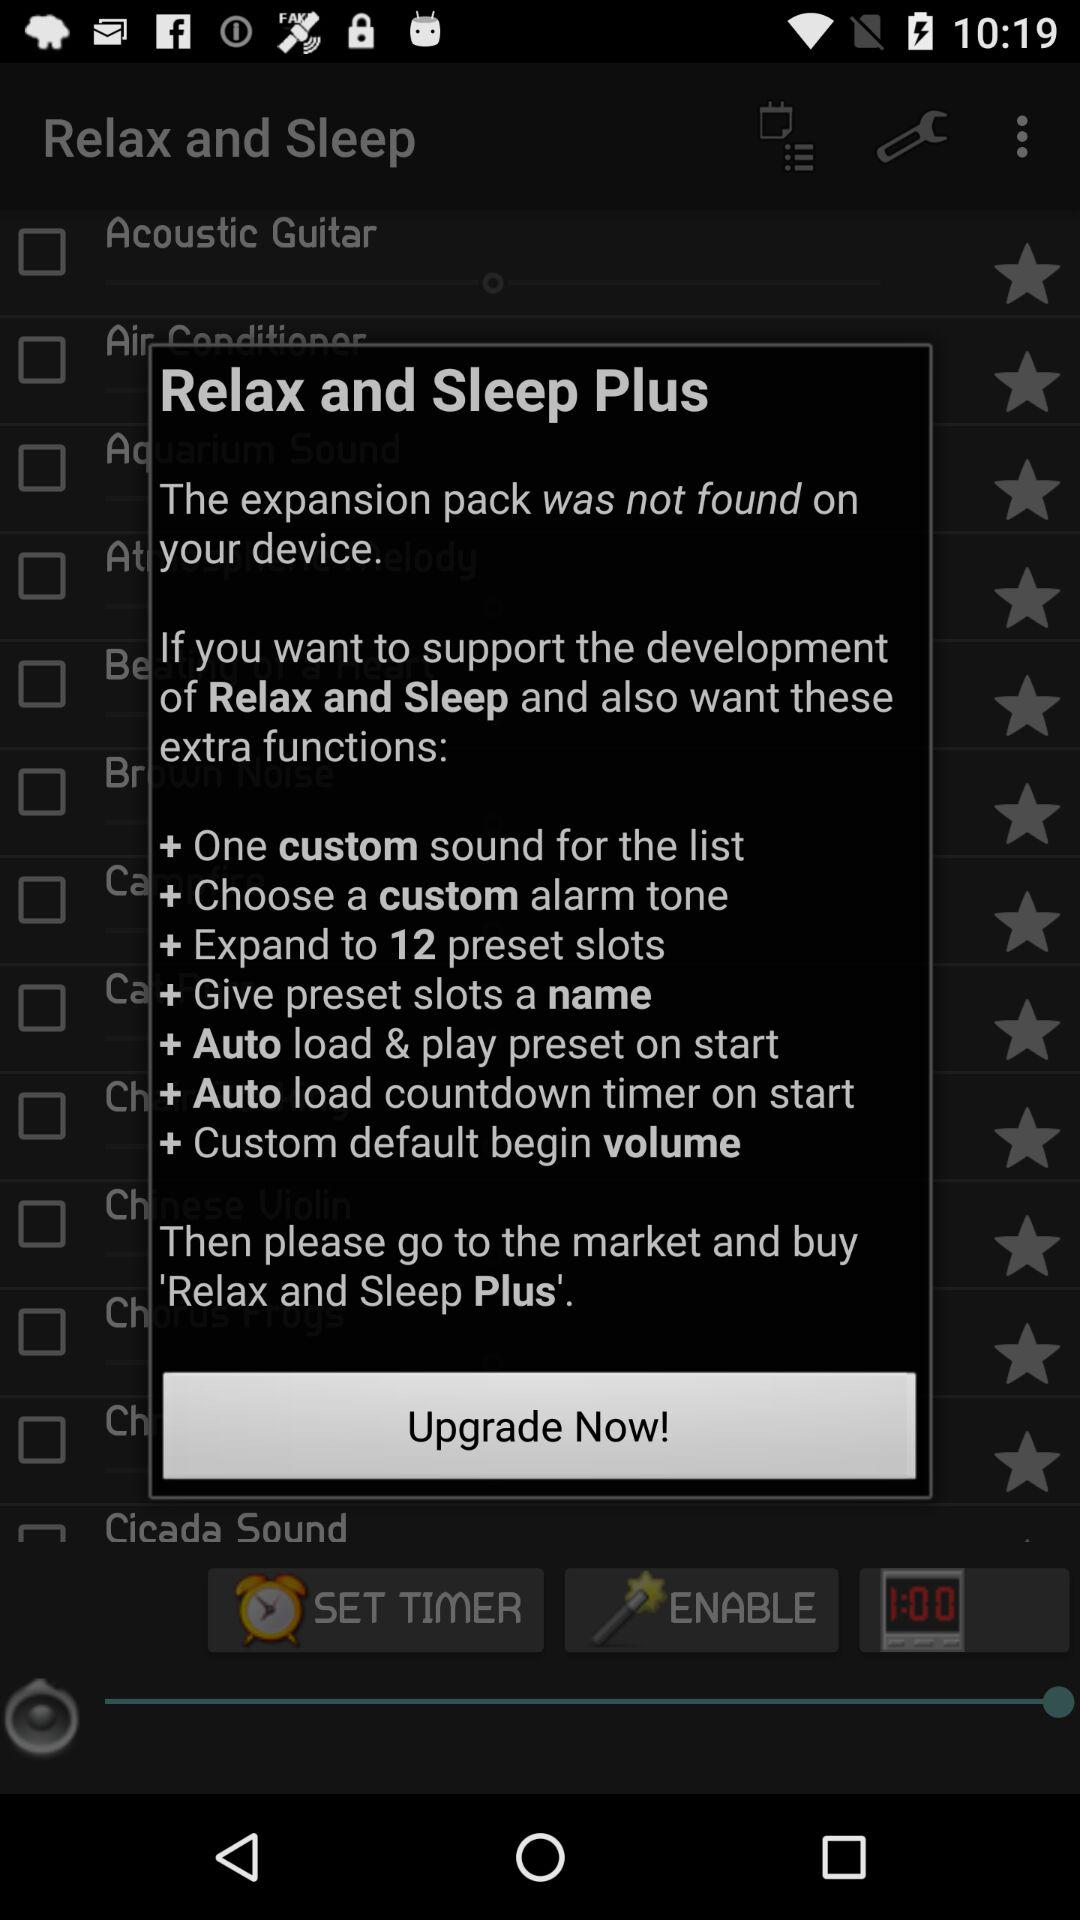How many preset slots are available in the Plus version?
Answer the question using a single word or phrase. 12 